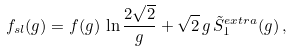<formula> <loc_0><loc_0><loc_500><loc_500>f _ { s l } ( g ) = f ( g ) \, \ln \frac { 2 \sqrt { 2 } } { g } + \sqrt { 2 } \, g \, \tilde { S } ^ { e x t r a } _ { 1 } ( g ) \, ,</formula> 